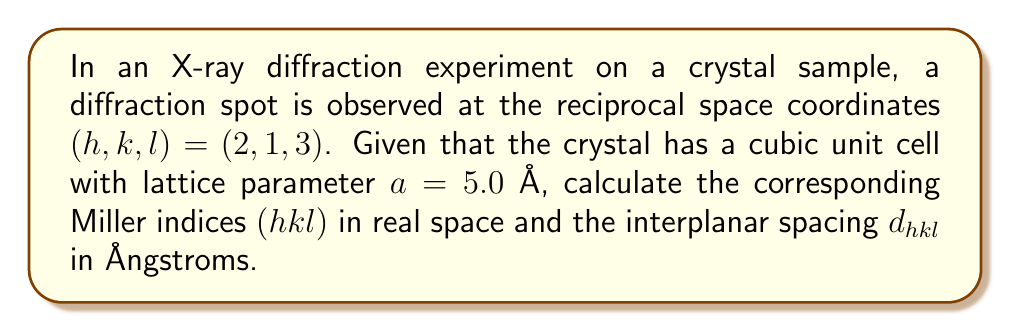Help me with this question. To solve this problem, we need to understand the relationship between reciprocal space and real space in crystallography, which is crucial for X-ray diffraction analysis in materials science.

1. Reciprocal space to real space conversion:
   In this case, the reciprocal space coordinates $(h,k,l)$ directly correspond to the Miller indices $(hkl)$ in real space. Therefore, no conversion is needed for the indices themselves.

2. Calculating the interplanar spacing $d_{hkl}$:
   For a cubic crystal system, the relationship between the interplanar spacing $d_{hkl}$ and the Miller indices $(hkl)$ is given by:

   $$\frac{1}{d_{hkl}^2} = \frac{h^2 + k^2 + l^2}{a^2}$$

   where $a$ is the lattice parameter.

   Rearranging this equation, we get:

   $$d_{hkl} = \frac{a}{\sqrt{h^2 + k^2 + l^2}}$$

3. Substituting the given values:
   $h = 2$, $k = 1$, $l = 3$, and $a = 5.0$ Å

   $$d_{hkl} = \frac{5.0}{\sqrt{2^2 + 1^2 + 3^2}}$$

4. Simplifying:
   $$d_{hkl} = \frac{5.0}{\sqrt{4 + 1 + 9}} = \frac{5.0}{\sqrt{14}}$$

5. Calculating the final result:
   $$d_{hkl} = \frac{5.0}{\sqrt{14}} \approx 1.34 \text{ Å}$$
Answer: The Miller indices in real space are $(hkl) = (213)$, and the interplanar spacing $d_{hkl} \approx 1.34$ Å. 